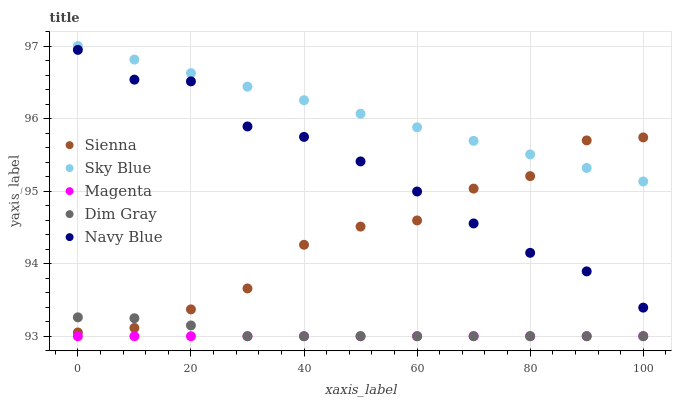Does Magenta have the minimum area under the curve?
Answer yes or no. Yes. Does Sky Blue have the maximum area under the curve?
Answer yes or no. Yes. Does Sky Blue have the minimum area under the curve?
Answer yes or no. No. Does Magenta have the maximum area under the curve?
Answer yes or no. No. Is Magenta the smoothest?
Answer yes or no. Yes. Is Sienna the roughest?
Answer yes or no. Yes. Is Sky Blue the smoothest?
Answer yes or no. No. Is Sky Blue the roughest?
Answer yes or no. No. Does Magenta have the lowest value?
Answer yes or no. Yes. Does Sky Blue have the lowest value?
Answer yes or no. No. Does Sky Blue have the highest value?
Answer yes or no. Yes. Does Magenta have the highest value?
Answer yes or no. No. Is Navy Blue less than Sky Blue?
Answer yes or no. Yes. Is Navy Blue greater than Magenta?
Answer yes or no. Yes. Does Magenta intersect Dim Gray?
Answer yes or no. Yes. Is Magenta less than Dim Gray?
Answer yes or no. No. Is Magenta greater than Dim Gray?
Answer yes or no. No. Does Navy Blue intersect Sky Blue?
Answer yes or no. No. 